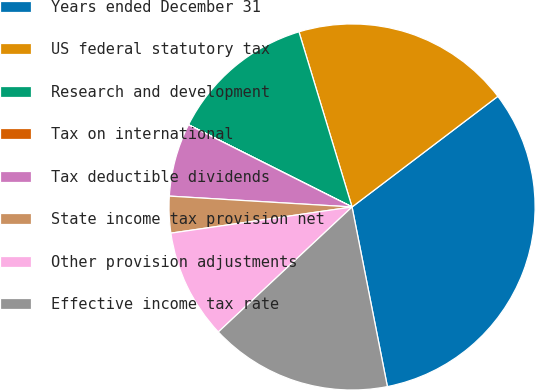Convert chart. <chart><loc_0><loc_0><loc_500><loc_500><pie_chart><fcel>Years ended December 31<fcel>US federal statutory tax<fcel>Research and development<fcel>Tax on international<fcel>Tax deductible dividends<fcel>State income tax provision net<fcel>Other provision adjustments<fcel>Effective income tax rate<nl><fcel>32.24%<fcel>19.35%<fcel>12.9%<fcel>0.01%<fcel>6.46%<fcel>3.23%<fcel>9.68%<fcel>16.13%<nl></chart> 